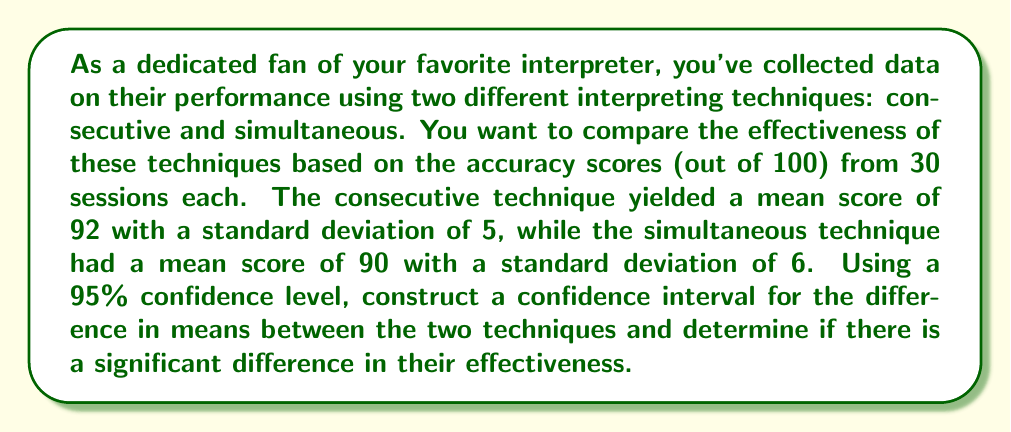Teach me how to tackle this problem. Let's approach this step-by-step:

1) We have two independent samples:
   Consecutive: $n_1 = 30$, $\bar{x}_1 = 92$, $s_1 = 5$
   Simultaneous: $n_2 = 30$, $\bar{x}_2 = 90$, $s_2 = 6$

2) We want to construct a confidence interval for $\mu_1 - \mu_2$, where $\mu_1$ and $\mu_2$ are the population means for consecutive and simultaneous techniques respectively.

3) The formula for the confidence interval is:

   $$(\bar{x}_1 - \bar{x}_2) \pm t_{\alpha/2} \sqrt{\frac{s_1^2}{n_1} + \frac{s_2^2}{n_2}}$$

   where $t_{\alpha/2}$ is the t-value for a 95% confidence level with degrees of freedom:

   $$df = \frac{(\frac{s_1^2}{n_1} + \frac{s_2^2}{n_2})^2}{\frac{(s_1^2/n_1)^2}{n_1-1} + \frac{(s_2^2/n_2)^2}{n_2-1}}$$

4) Calculate the degrees of freedom:

   $$df = \frac{(\frac{5^2}{30} + \frac{6^2}{30})^2}{\frac{(5^2/30)^2}{29} + \frac{(6^2/30)^2}{29}} \approx 56.78$$

   Round down to 56 for a conservative estimate.

5) For df = 56 and 95% confidence level, $t_{\alpha/2} \approx 2.003$

6) Now, calculate the confidence interval:

   $$\begin{align}
   (92 - 90) &\pm 2.003 \sqrt{\frac{5^2}{30} + \frac{6^2}{30}} \\
   2 &\pm 2.003 \sqrt{\frac{25}{30} + \frac{36}{30}} \\
   2 &\pm 2.003 \sqrt{\frac{61}{30}} \\
   2 &\pm 2.003 (1.425) \\
   2 &\pm 2.854
   \end{align}$$

7) Therefore, the 95% confidence interval is (-0.854, 4.854).

8) Since this interval does not include 0, we can conclude that there is a significant difference between the two techniques at the 95% confidence level.
Answer: 95% CI: (-0.854, 4.854); significant difference exists 